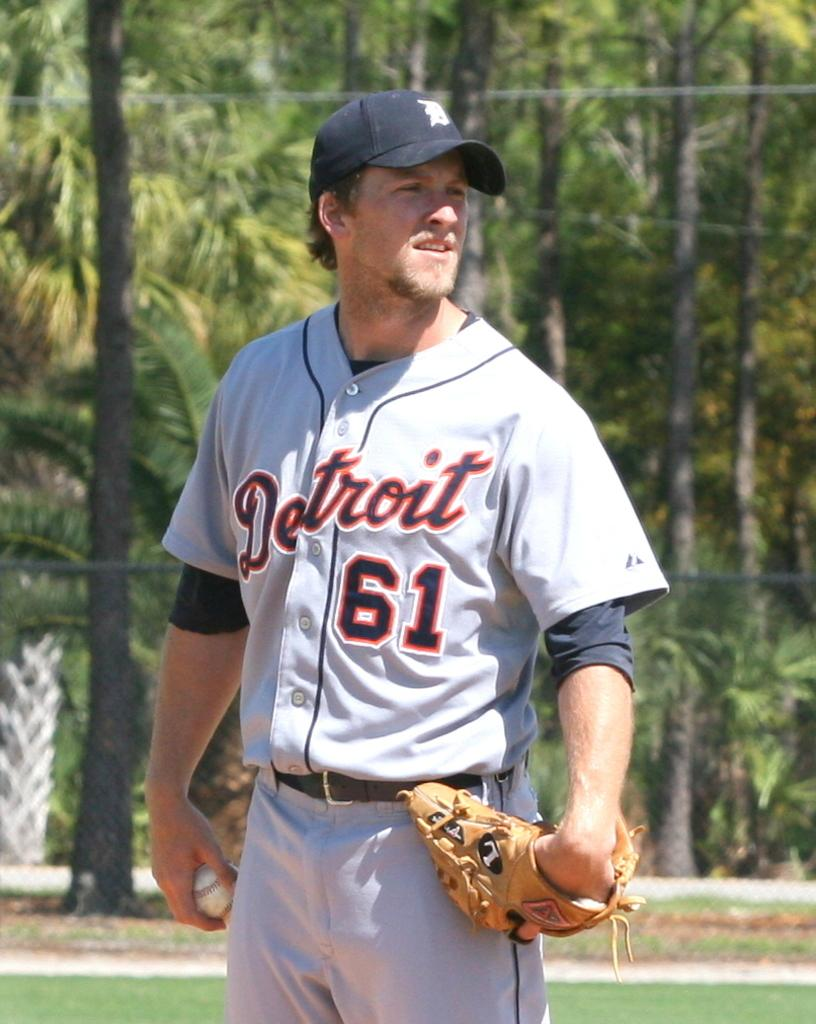<image>
Relay a brief, clear account of the picture shown. a Detroit pitcher looking in for a sign 